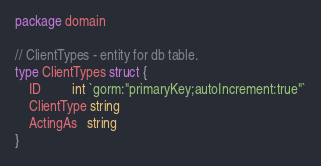Convert code to text. <code><loc_0><loc_0><loc_500><loc_500><_Go_>package domain

// ClientTypes - entity for db table.
type ClientTypes struct {
	ID         int `gorm:"primaryKey;autoIncrement:true"`
	ClientType string
	ActingAs   string
}
</code> 